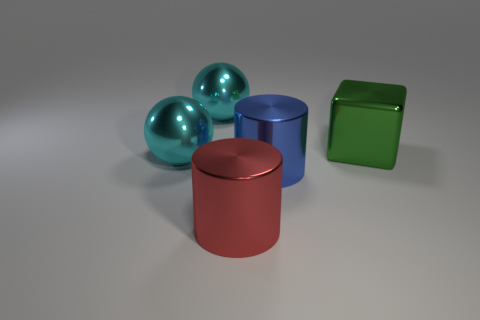Add 2 green blocks. How many objects exist? 7 Subtract all cylinders. How many objects are left? 3 Add 1 large objects. How many large objects are left? 6 Add 2 blue objects. How many blue objects exist? 3 Subtract 0 gray cubes. How many objects are left? 5 Subtract all big cyan things. Subtract all shiny cubes. How many objects are left? 2 